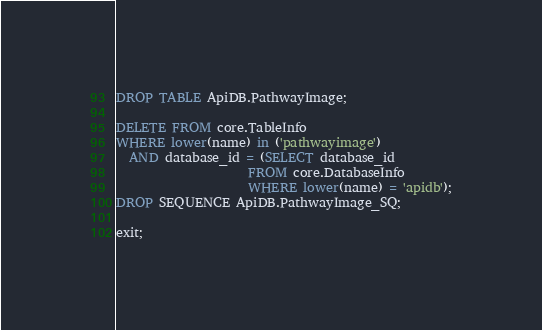<code> <loc_0><loc_0><loc_500><loc_500><_SQL_>DROP TABLE ApiDB.PathwayImage;

DELETE FROM core.TableInfo
WHERE lower(name) in ('pathwayimage')
  AND database_id = (SELECT database_id
                     FROM core.DatabaseInfo
                     WHERE lower(name) = 'apidb');
DROP SEQUENCE ApiDB.PathwayImage_SQ;

exit;
</code> 